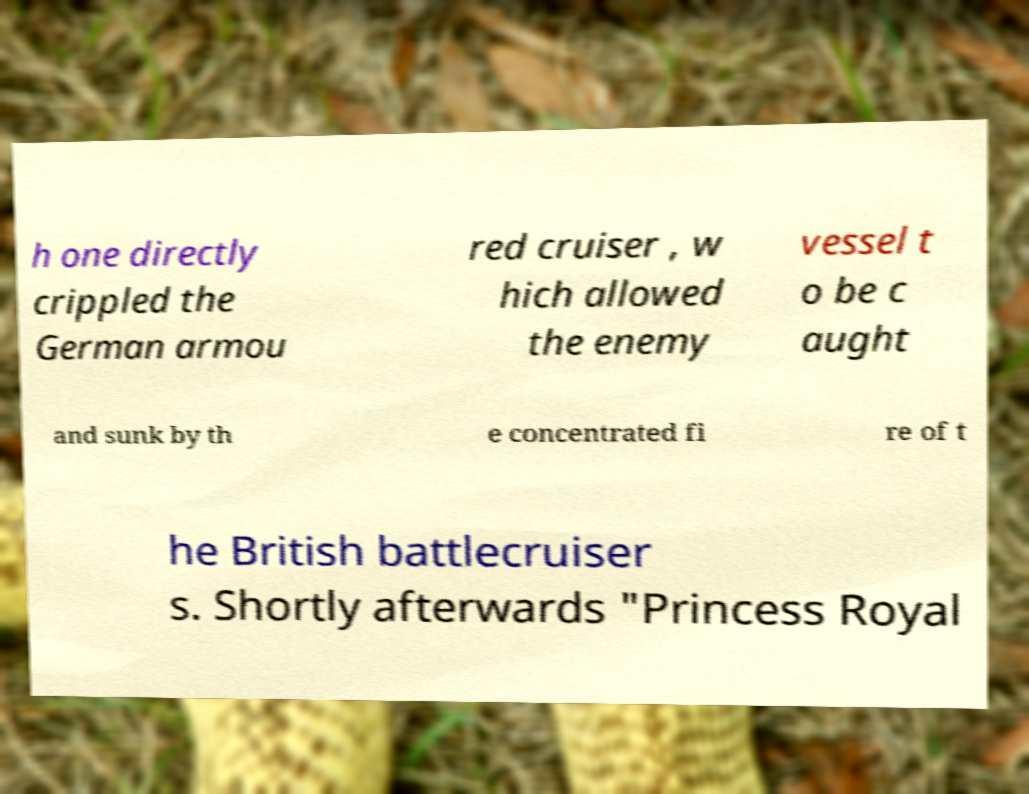Could you extract and type out the text from this image? h one directly crippled the German armou red cruiser , w hich allowed the enemy vessel t o be c aught and sunk by th e concentrated fi re of t he British battlecruiser s. Shortly afterwards "Princess Royal 